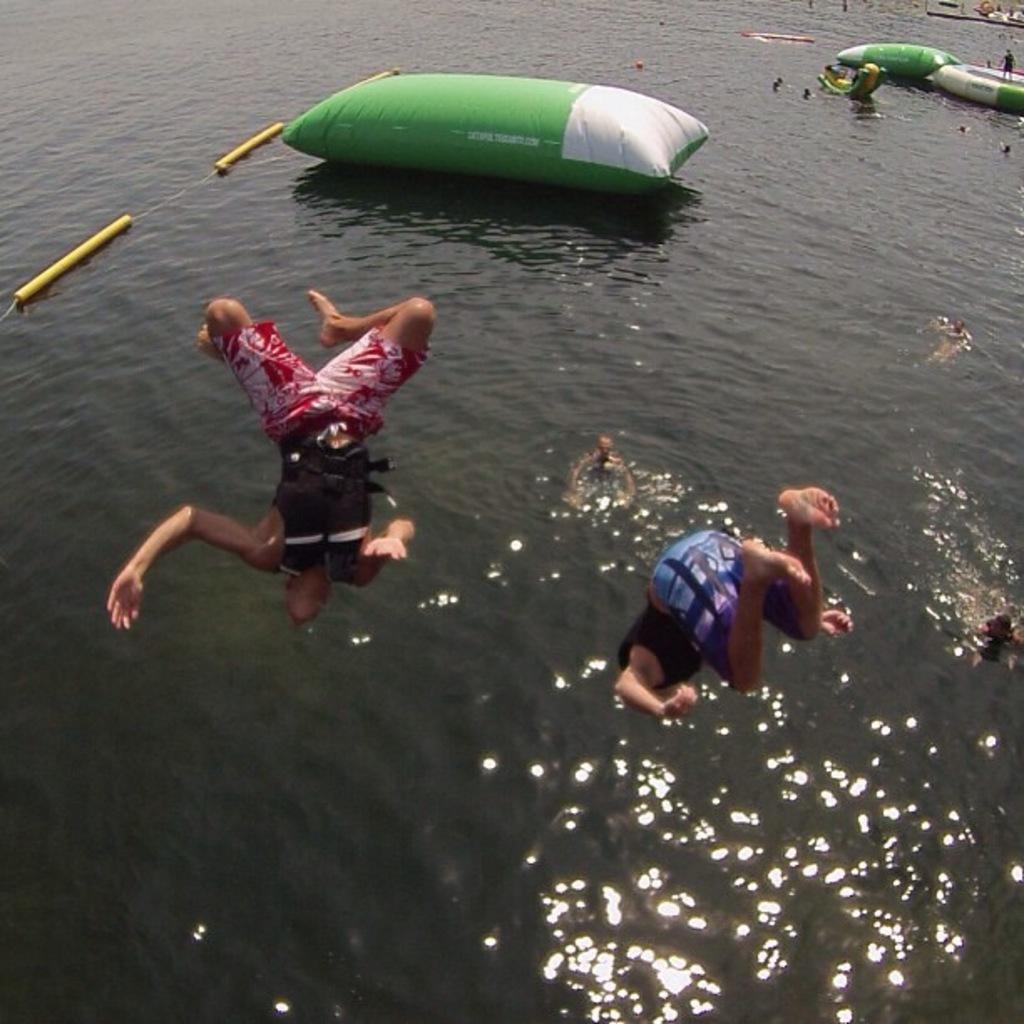Can you describe this image briefly? This image is taken outdoors. At the bottom of the image there is a river with water. In the middle of the image two men are diving and a few men are swimming in the river. At the top of the image there are a few floating tubes on the river and there are a few people. 